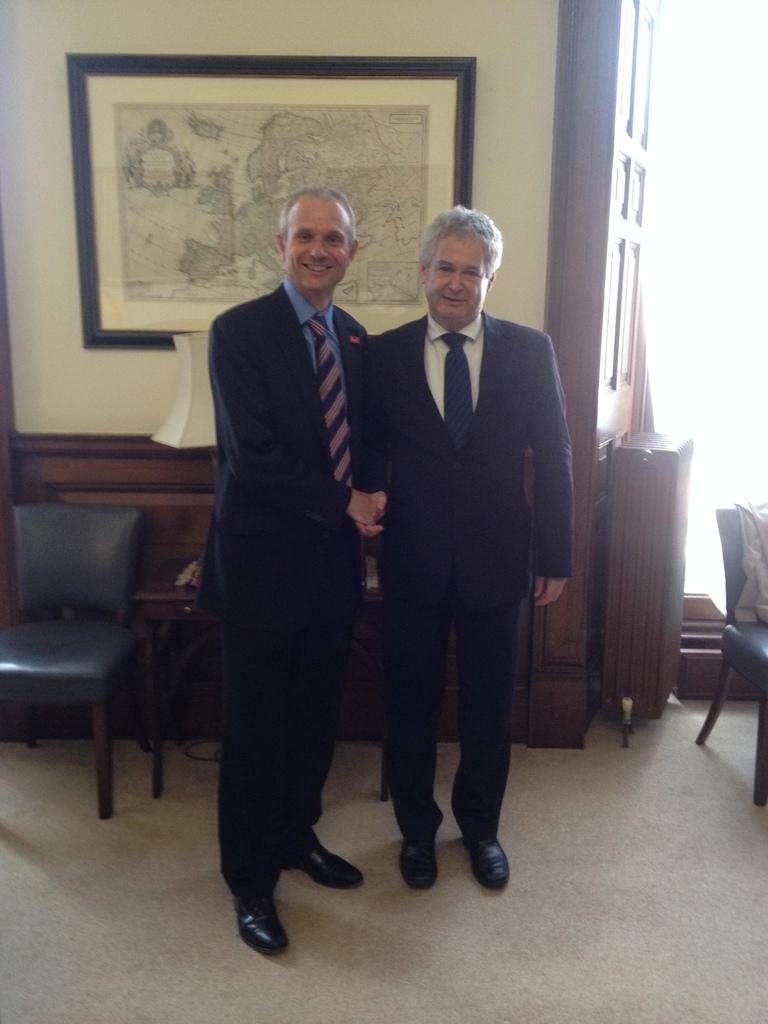How many people are in the image? There are two men in the image. What are the men wearing? The men are wearing black suits. What are the men doing with their hands? The men are holding their hands together. What piece of furniture is in the image? There is a chair in the image. What is on the wall in the image? There is a photo on the wall in the image. How many cats are sitting on the chair in the image? There are no cats present in the image; it only features two men in black suits. What type of class is being taught in the image? There is no class or teaching activity depicted in the image. 